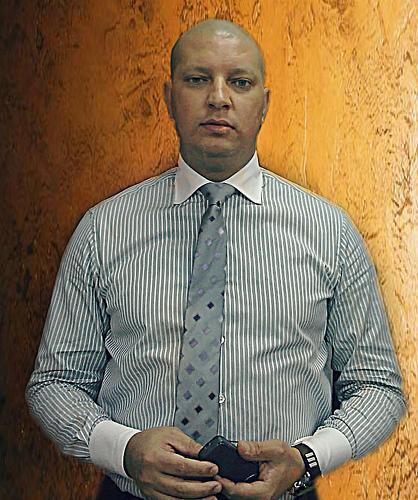How many men are in the picture?
Give a very brief answer. 1. 